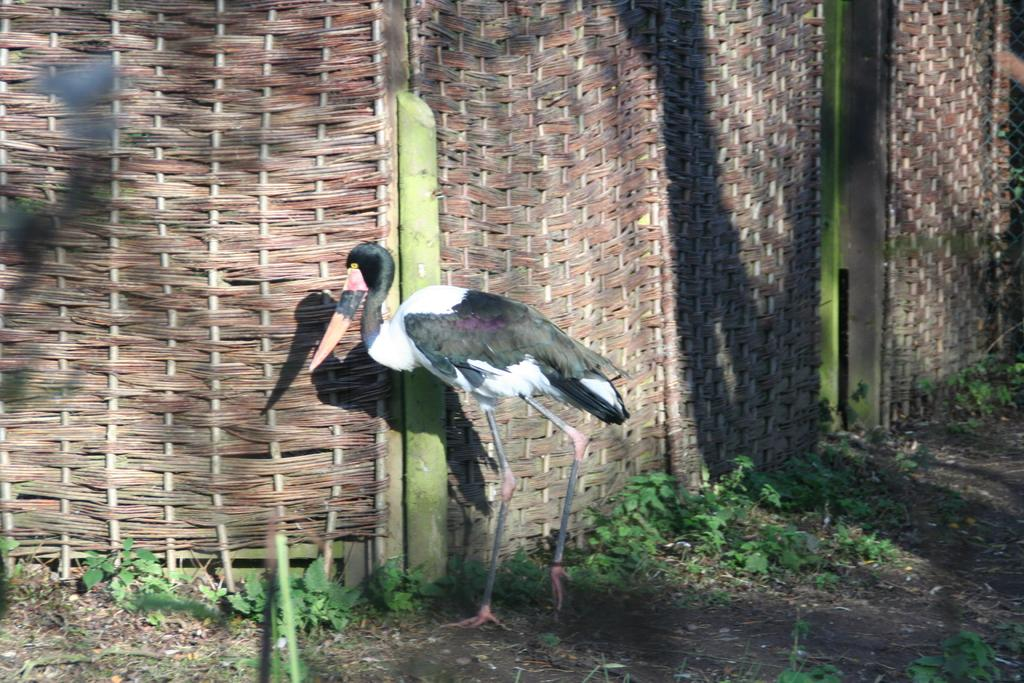What is the main subject of the image? There is a crane in the image. What is the crane doing in the image? The crane is walking on the ground. What type of vegetation can be seen on the ground? There are plants and grass on the ground. What can be seen in the background of the image? There is a wall in the background of the image. What type of prose is being recited by the crane during its afterthought in the image? There is no indication in the image that the crane is reciting any prose or experiencing an afterthought. 